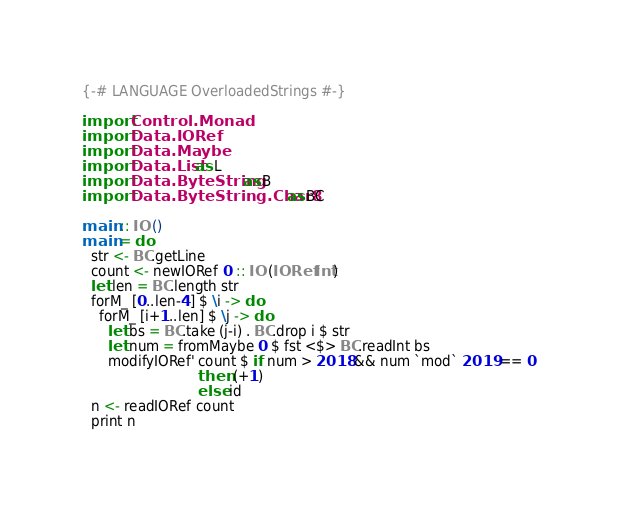Convert code to text. <code><loc_0><loc_0><loc_500><loc_500><_Haskell_>{-# LANGUAGE OverloadedStrings #-}

import Control.Monad
import Data.IORef
import Data.Maybe
import Data.List as L
import Data.ByteString as B
import Data.ByteString.Char8 as BC

main :: IO ()
main = do
  str <- BC.getLine
  count <- newIORef 0 :: IO (IORef Int)
  let len = BC.length str
  forM_ [0..len-4] $ \i -> do
    forM_ [i+1..len] $ \j -> do
      let bs = BC.take (j-i) . BC.drop i $ str
      let num = fromMaybe 0 $ fst <$> BC.readInt bs
      modifyIORef' count $ if num > 2018 && num `mod` 2019 == 0
                           then (+1)
                           else id
  n <- readIORef count
  print n
</code> 